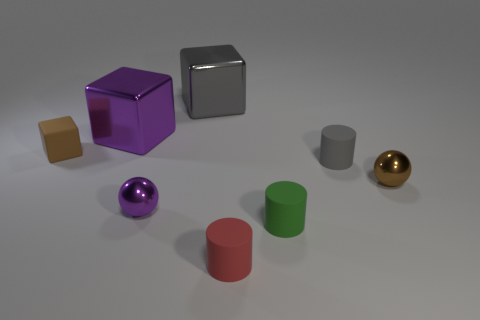Subtract all small gray matte cylinders. How many cylinders are left? 2 Add 2 brown rubber cylinders. How many objects exist? 10 Subtract all gray cylinders. How many cylinders are left? 2 Subtract all cubes. How many objects are left? 5 Subtract 1 green cylinders. How many objects are left? 7 Subtract 3 cylinders. How many cylinders are left? 0 Subtract all blue blocks. Subtract all blue spheres. How many blocks are left? 3 Subtract all big yellow shiny cylinders. Subtract all small purple spheres. How many objects are left? 7 Add 5 tiny matte objects. How many tiny matte objects are left? 9 Add 8 green things. How many green things exist? 9 